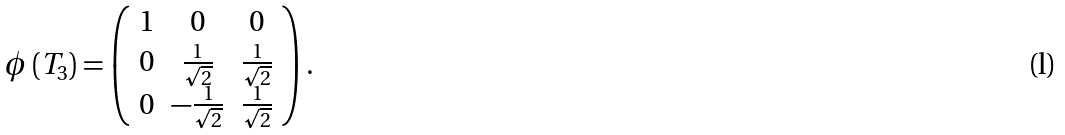Convert formula to latex. <formula><loc_0><loc_0><loc_500><loc_500>\phi \left ( T _ { 3 } \right ) = \left ( \begin{array} { c c c } 1 & 0 & 0 \\ 0 & \frac { 1 } { \sqrt { 2 } } & \frac { 1 } { \sqrt { 2 } } \\ 0 & - \frac { 1 } { \sqrt { 2 } } & \frac { 1 } { \sqrt { 2 } } \end{array} \right ) .</formula> 